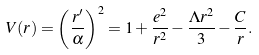Convert formula to latex. <formula><loc_0><loc_0><loc_500><loc_500>V ( r ) = \left ( \frac { r ^ { \prime } } { \alpha } \right ) ^ { 2 } = 1 + \frac { e ^ { 2 } } { r ^ { 2 } } - \frac { \Lambda r ^ { 2 } } { 3 } - \frac { C } { r } .</formula> 